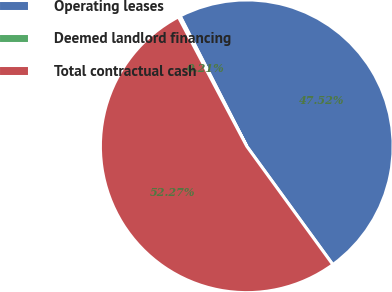<chart> <loc_0><loc_0><loc_500><loc_500><pie_chart><fcel>Operating leases<fcel>Deemed landlord financing<fcel>Total contractual cash<nl><fcel>47.52%<fcel>0.21%<fcel>52.27%<nl></chart> 